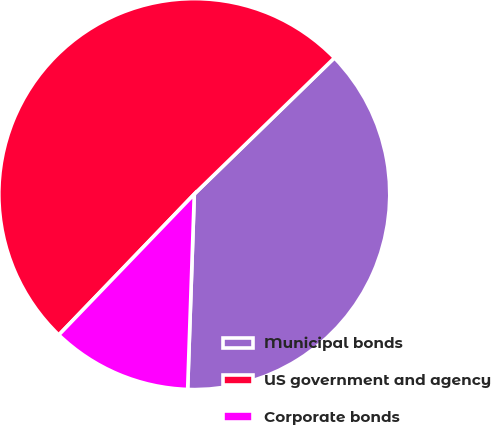Convert chart to OTSL. <chart><loc_0><loc_0><loc_500><loc_500><pie_chart><fcel>Municipal bonds<fcel>US government and agency<fcel>Corporate bonds<nl><fcel>37.82%<fcel>50.53%<fcel>11.65%<nl></chart> 